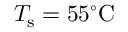<formula> <loc_0><loc_0><loc_500><loc_500>T _ { s } = 5 5 ^ { \circ } C</formula> 